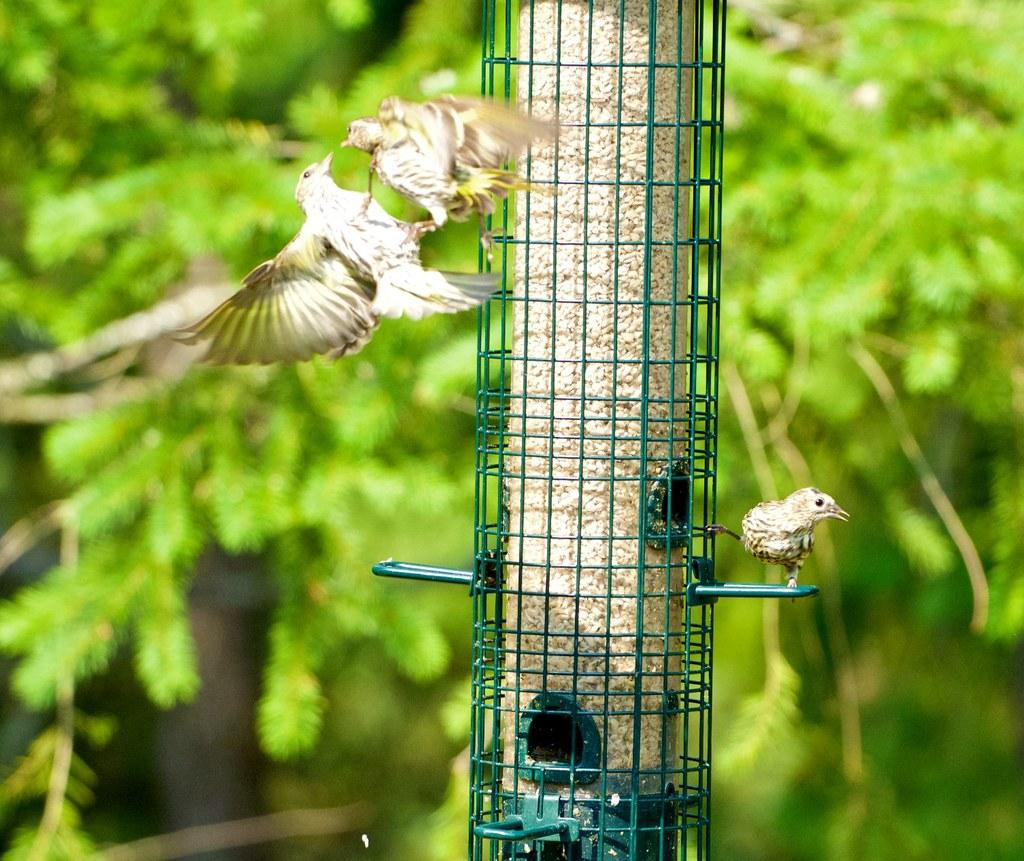What is located in the foreground of the image? There is a bird on the bird feeding station in the foreground. How many birds are visible in the image? There are three birds visible in the image, including the one on the feeding station and two additional birds in the air. What can be seen in the background of the image? There is greenery visible in the background. What type of pickle is being used to transport the birds in the image? There is no pickle or transportation of birds present in the image; it features birds on a feeding station and in the air. 